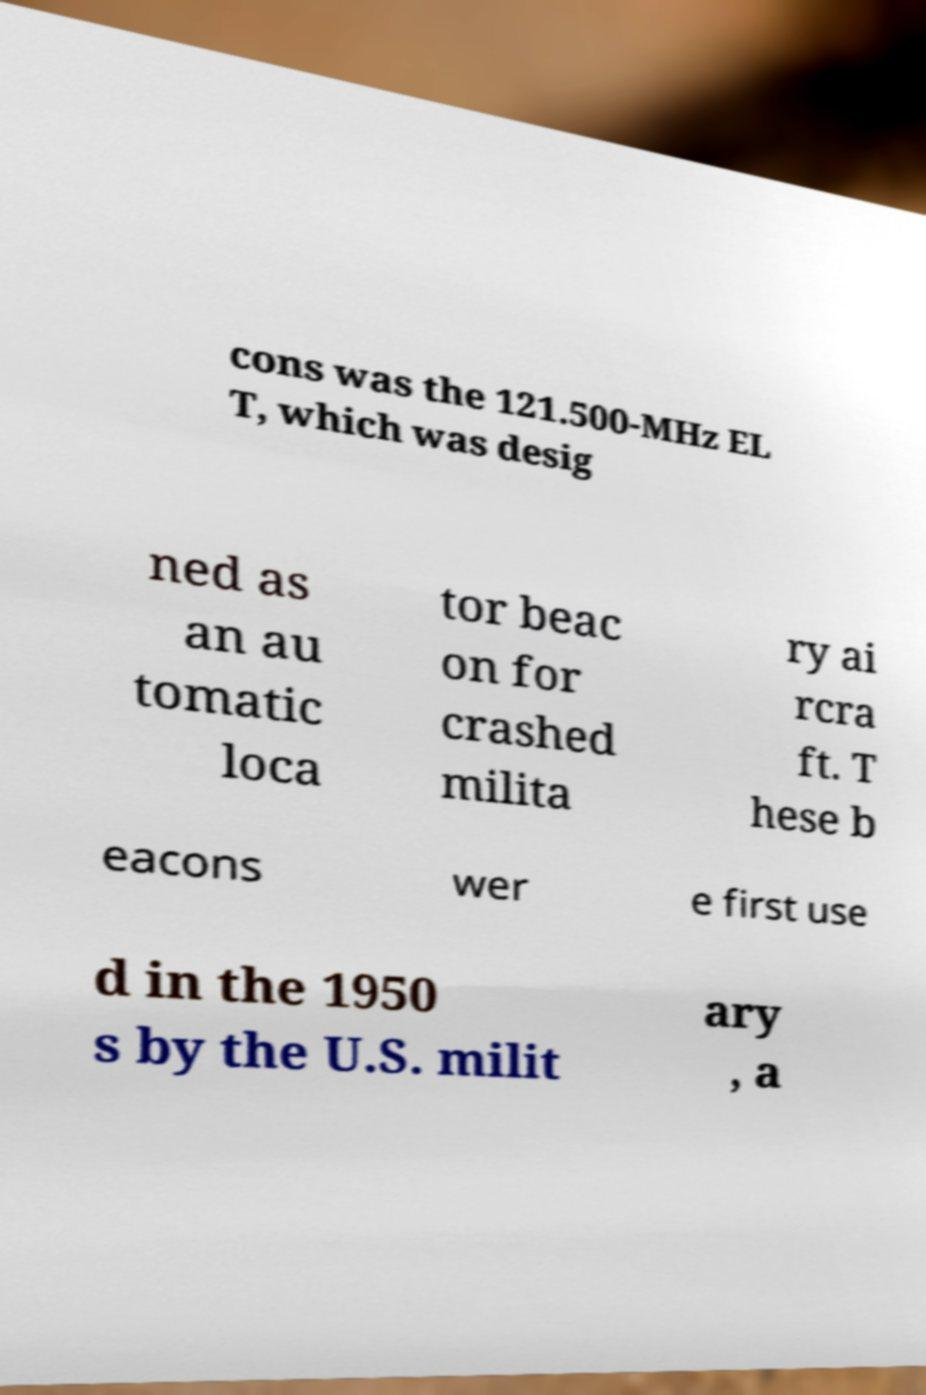For documentation purposes, I need the text within this image transcribed. Could you provide that? cons was the 121.500-MHz EL T, which was desig ned as an au tomatic loca tor beac on for crashed milita ry ai rcra ft. T hese b eacons wer e first use d in the 1950 s by the U.S. milit ary , a 